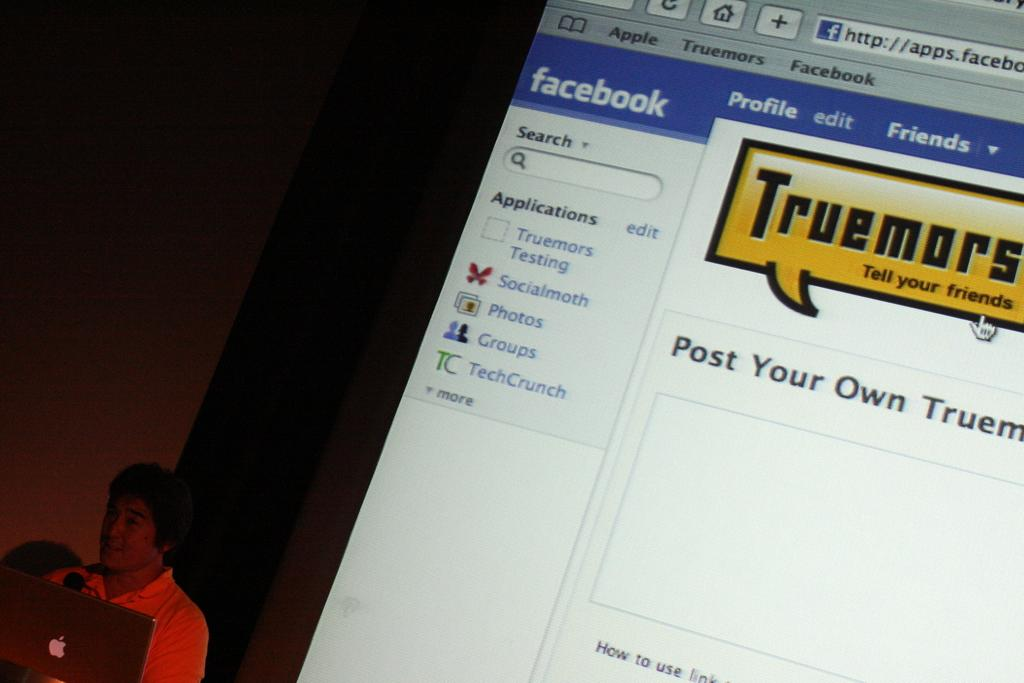What electronic device is located in the bottom left corner of the image? There is a laptop in the bottom left corner of the image. Who is present in the image behind the laptop? There is a man behind the laptop. What can be seen on the screen behind the man? There is a screen with a Facebook page visible behind the man. What type of crack is visible on the laptop screen in the image? There is no crack visible on the laptop screen in the image. How does the water affect the laptop in the image? There is no water present in the image, so it cannot affect the laptop. 